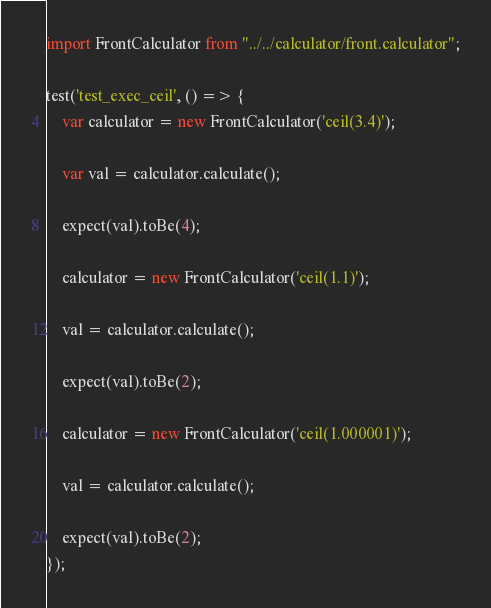Convert code to text. <code><loc_0><loc_0><loc_500><loc_500><_JavaScript_>import FrontCalculator from "../../calculator/front.calculator";

test('test_exec_ceil', () => {
	var calculator = new FrontCalculator('ceil(3.4)');

	var val = calculator.calculate();

	expect(val).toBe(4);

	calculator = new FrontCalculator('ceil(1.1)');

	val = calculator.calculate();

	expect(val).toBe(2);

	calculator = new FrontCalculator('ceil(1.000001)');

	val = calculator.calculate();

	expect(val).toBe(2);
});
</code> 